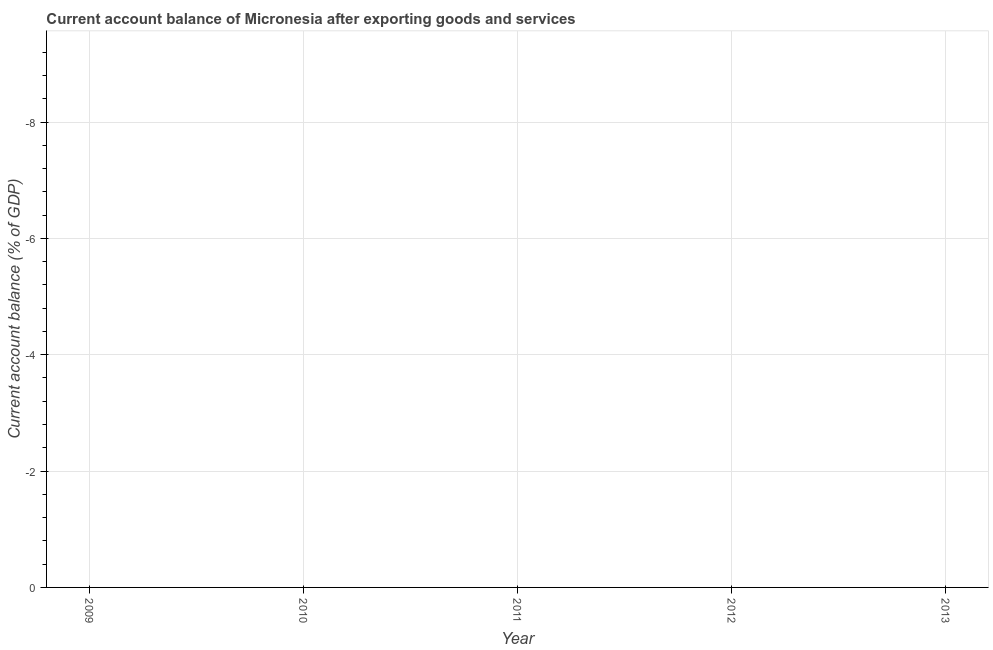What is the current account balance in 2011?
Keep it short and to the point. 0. In how many years, is the current account balance greater than -1.6 %?
Your response must be concise. 0. In how many years, is the current account balance greater than the average current account balance taken over all years?
Provide a succinct answer. 0. How many lines are there?
Your answer should be compact. 0. Are the values on the major ticks of Y-axis written in scientific E-notation?
Provide a short and direct response. No. Does the graph contain grids?
Your answer should be compact. Yes. What is the title of the graph?
Provide a succinct answer. Current account balance of Micronesia after exporting goods and services. What is the label or title of the X-axis?
Provide a short and direct response. Year. What is the label or title of the Y-axis?
Keep it short and to the point. Current account balance (% of GDP). What is the Current account balance (% of GDP) of 2010?
Offer a very short reply. 0. What is the Current account balance (% of GDP) of 2011?
Keep it short and to the point. 0. What is the Current account balance (% of GDP) in 2012?
Give a very brief answer. 0. 